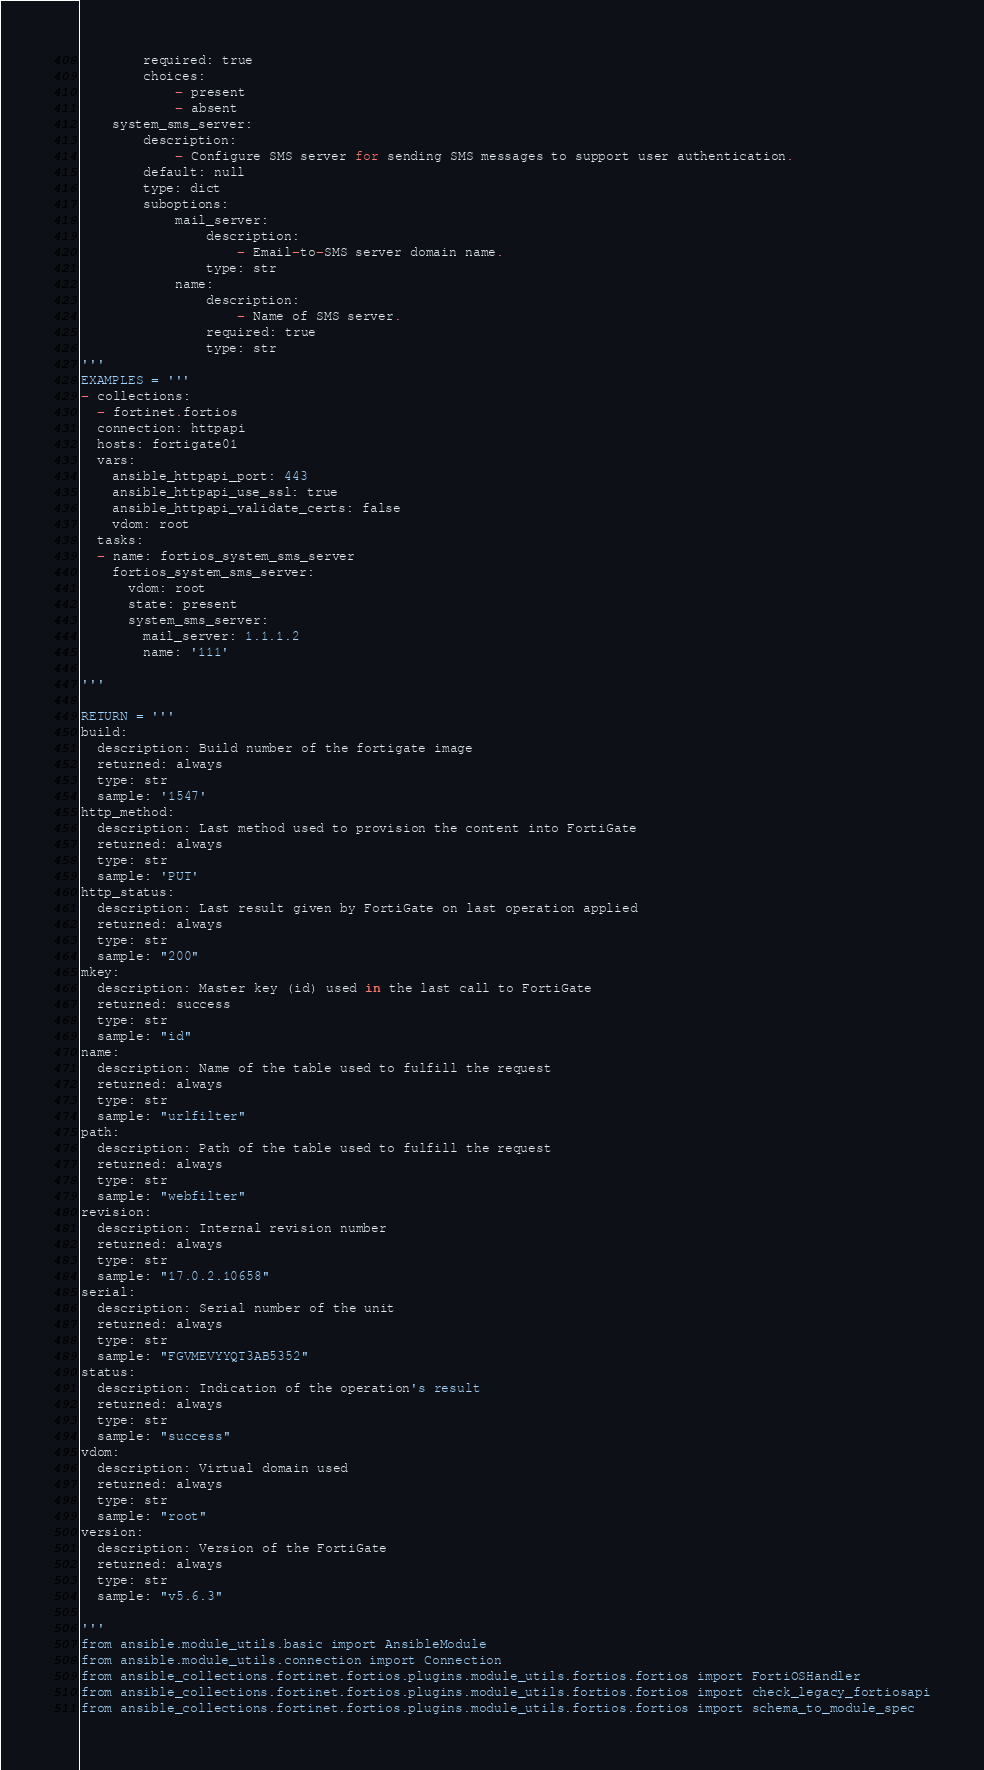<code> <loc_0><loc_0><loc_500><loc_500><_Python_>        required: true
        choices:
            - present
            - absent
    system_sms_server:
        description:
            - Configure SMS server for sending SMS messages to support user authentication.
        default: null
        type: dict
        suboptions:
            mail_server:
                description:
                    - Email-to-SMS server domain name.
                type: str
            name:
                description:
                    - Name of SMS server.
                required: true
                type: str
'''
EXAMPLES = '''
- collections:
  - fortinet.fortios
  connection: httpapi
  hosts: fortigate01
  vars:
    ansible_httpapi_port: 443
    ansible_httpapi_use_ssl: true
    ansible_httpapi_validate_certs: false
    vdom: root
  tasks:
  - name: fortios_system_sms_server
    fortios_system_sms_server:
      vdom: root
      state: present
      system_sms_server:
        mail_server: 1.1.1.2
        name: '111'

'''

RETURN = '''
build:
  description: Build number of the fortigate image
  returned: always
  type: str
  sample: '1547'
http_method:
  description: Last method used to provision the content into FortiGate
  returned: always
  type: str
  sample: 'PUT'
http_status:
  description: Last result given by FortiGate on last operation applied
  returned: always
  type: str
  sample: "200"
mkey:
  description: Master key (id) used in the last call to FortiGate
  returned: success
  type: str
  sample: "id"
name:
  description: Name of the table used to fulfill the request
  returned: always
  type: str
  sample: "urlfilter"
path:
  description: Path of the table used to fulfill the request
  returned: always
  type: str
  sample: "webfilter"
revision:
  description: Internal revision number
  returned: always
  type: str
  sample: "17.0.2.10658"
serial:
  description: Serial number of the unit
  returned: always
  type: str
  sample: "FGVMEVYYQT3AB5352"
status:
  description: Indication of the operation's result
  returned: always
  type: str
  sample: "success"
vdom:
  description: Virtual domain used
  returned: always
  type: str
  sample: "root"
version:
  description: Version of the FortiGate
  returned: always
  type: str
  sample: "v5.6.3"

'''
from ansible.module_utils.basic import AnsibleModule
from ansible.module_utils.connection import Connection
from ansible_collections.fortinet.fortios.plugins.module_utils.fortios.fortios import FortiOSHandler
from ansible_collections.fortinet.fortios.plugins.module_utils.fortios.fortios import check_legacy_fortiosapi
from ansible_collections.fortinet.fortios.plugins.module_utils.fortios.fortios import schema_to_module_spec</code> 